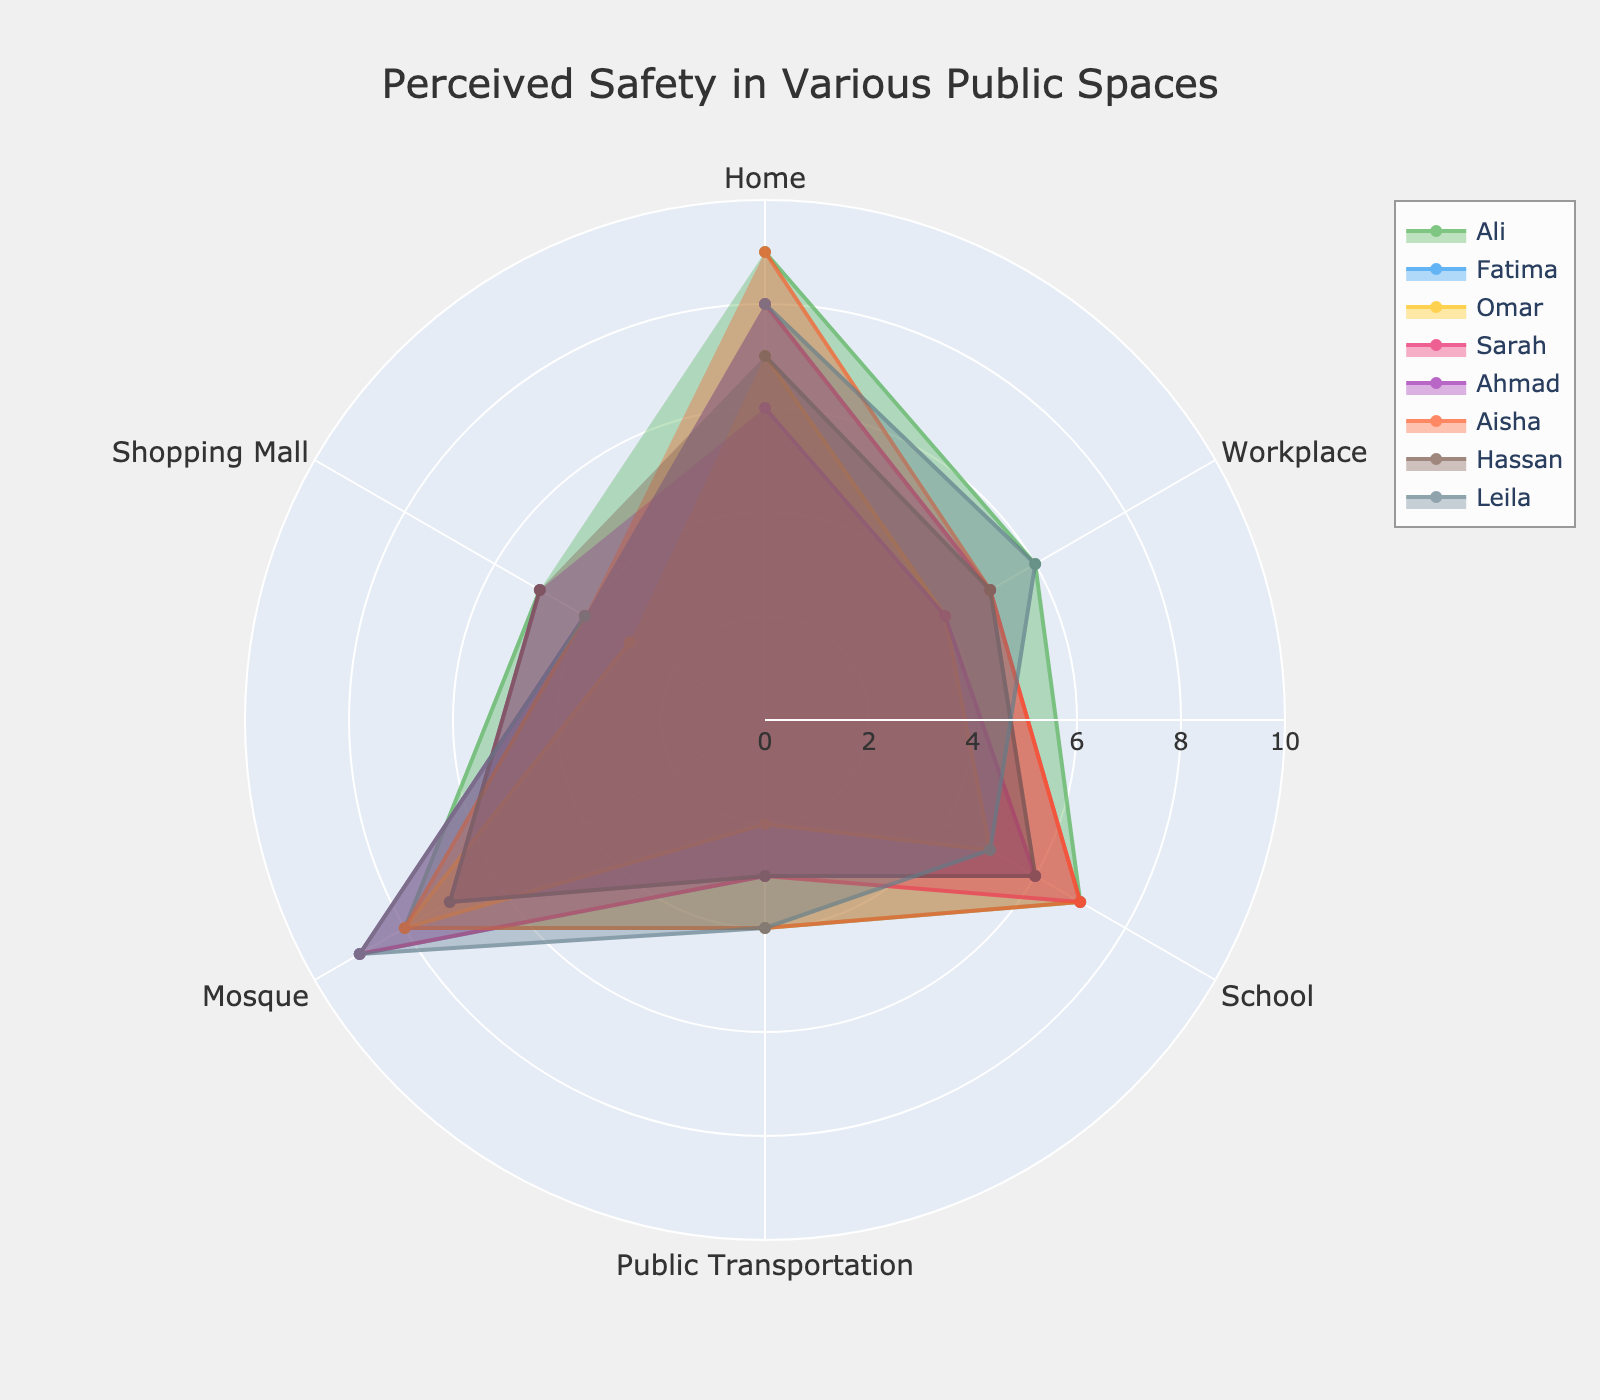What's the title of the figure? The title is typically displayed at the top of the figure, making it easily identifiable.
Answer: Perceived Safety in Various Public Spaces How many individuals' data are presented in the radar chart? By counting the names listed in the legend or the number of distinctive areas, we find that there are eight individuals.
Answer: Eight individuals Which category shows the highest perceived safety for Omar? By observing Omar's data points on the radar chart, we notice that the 'Home' category has the highest value.
Answer: Home In which category does Fatima report the lowest perceived safety? Examining Fatima's data points, the 'Public Transportation' category has the lowest value.
Answer: Public Transportation Compare the perceived safety values of Leila and Hassan at the Mosque. Who feels safer? Looking at the radar chart, Leila's value at the Mosque is higher than Hassan's.
Answer: Leila What's the average perceived safety value for Sarah across all categories? Sum Sarah's values: 8 + 5 + 7 + 3 + 9 + 4 = 36, then divide by the number of categories (6).
Answer: 6 Which category has the smallest range of perceived safety values among all individuals? Determine the range (max - min) for each category: Home, 9-6=3; Workplace, 6-3=3; School, 7-5=2; Public Transportation, 4-2=2; Mosque, 9-7=2; Shopping Mall, 5-3=2. Several categories have the smallest range of 2.
Answer: School, Public Transportation, Mosque, Shopping Mall Does Ahmad feel safer or less safe than Ali in the Workplace? Comparing Ahmad's and Ali's values in the Workplace category: Ahmad has 4 and Ali has 6.
Answer: Less safe What is the difference in perceived safety at Shopping Malls between Hassan and Aisha? Subtract Hassan's value from Aisha's value in the Shopping Mall category: 4 - 5 = -1.
Answer: -1 What is the highest perceived safety value across all individuals and categories? By scanning all values in the radar chart, the highest value is found in the 'Home' and 'Mosque' categories.
Answer: 9 